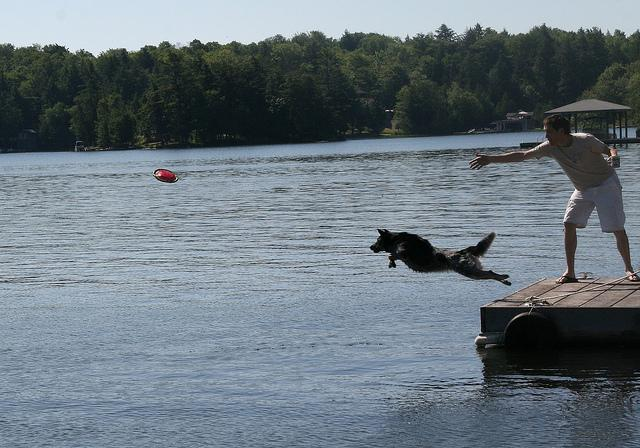What is the object called that the dog is jumping into the water after?

Choices:
A) football
B) ball
C) bone
D) frisbee frisbee 